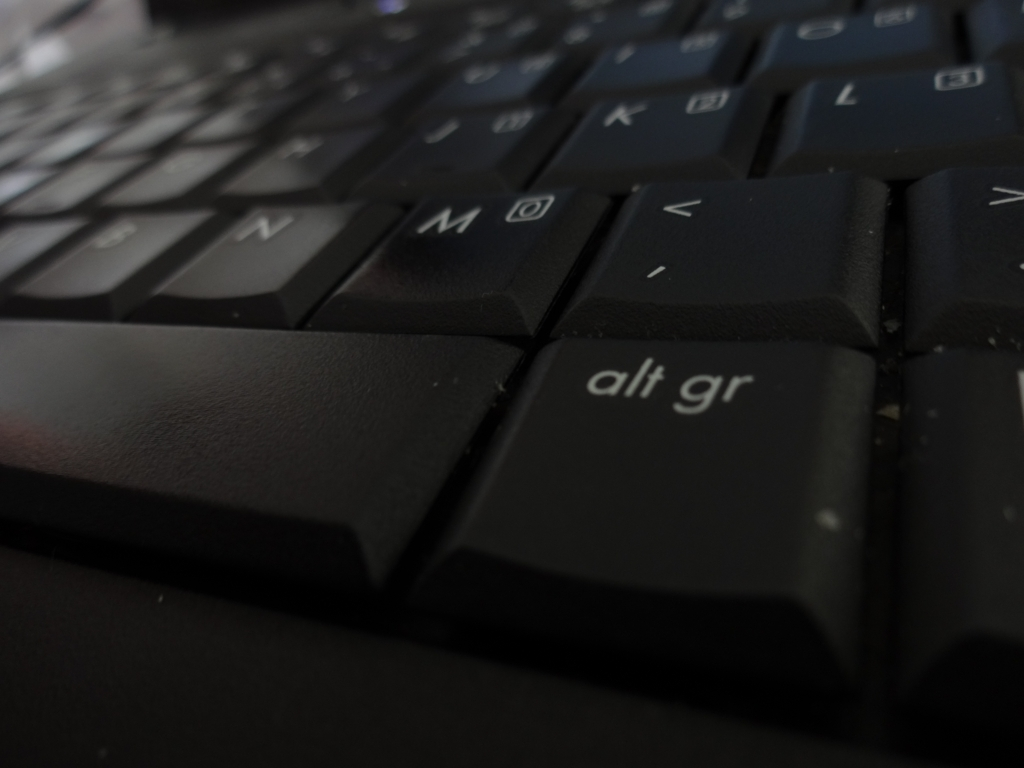Is the keyboard background at the top blurry? The keyboard background in the upper portion of the image is out of focus, with a shallow depth of field resulting in a soft, blurry effect. This technique draws attention to the foreground, making the keys that are in focus appear more pronounced. 